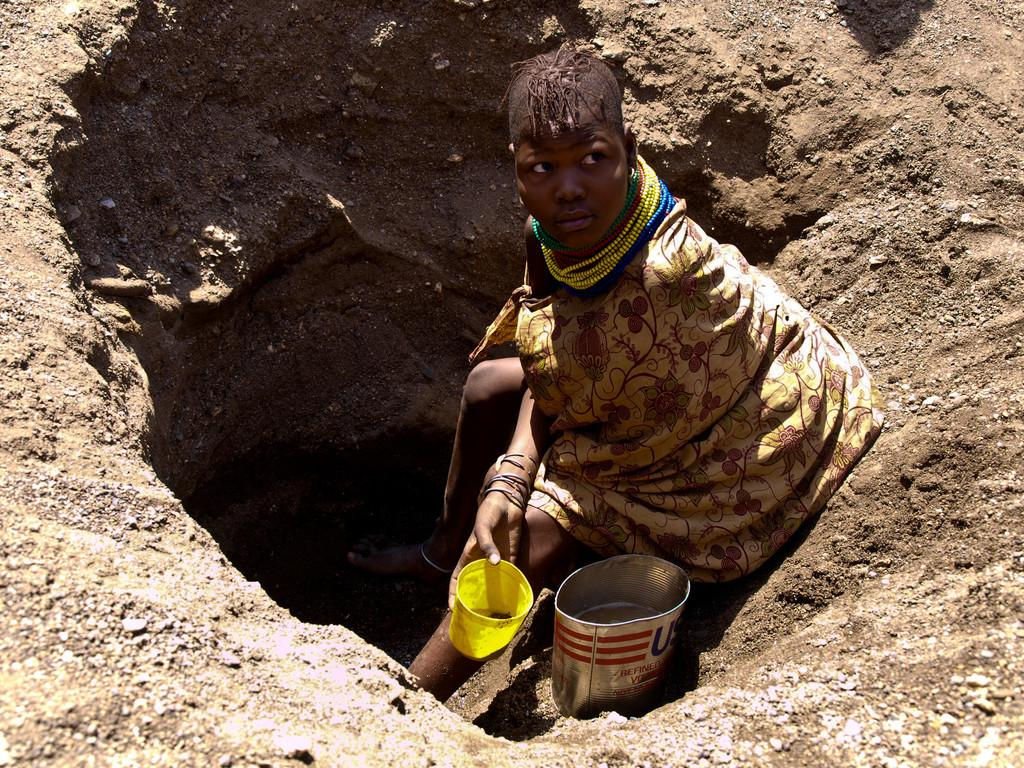Who is present in the image? There is a person in the image. What is the person wearing? The person is wearing a dress. What is the person holding in the image? The person is holding a green object. Where is the person standing in the image? The person is standing inside a dig. What class is the person attending in the image? There is no indication of a class or any educational setting in the image. 